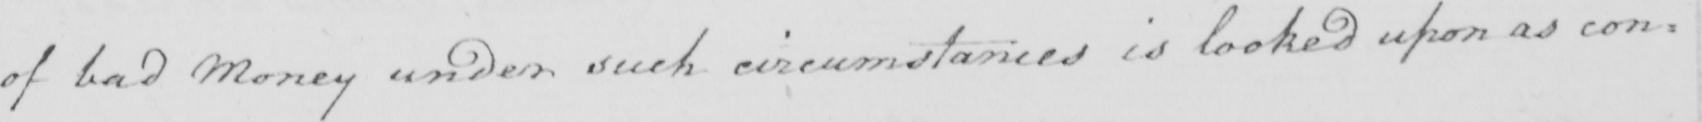What is written in this line of handwriting? of bad Money under such circumstances is looked upon as con= 